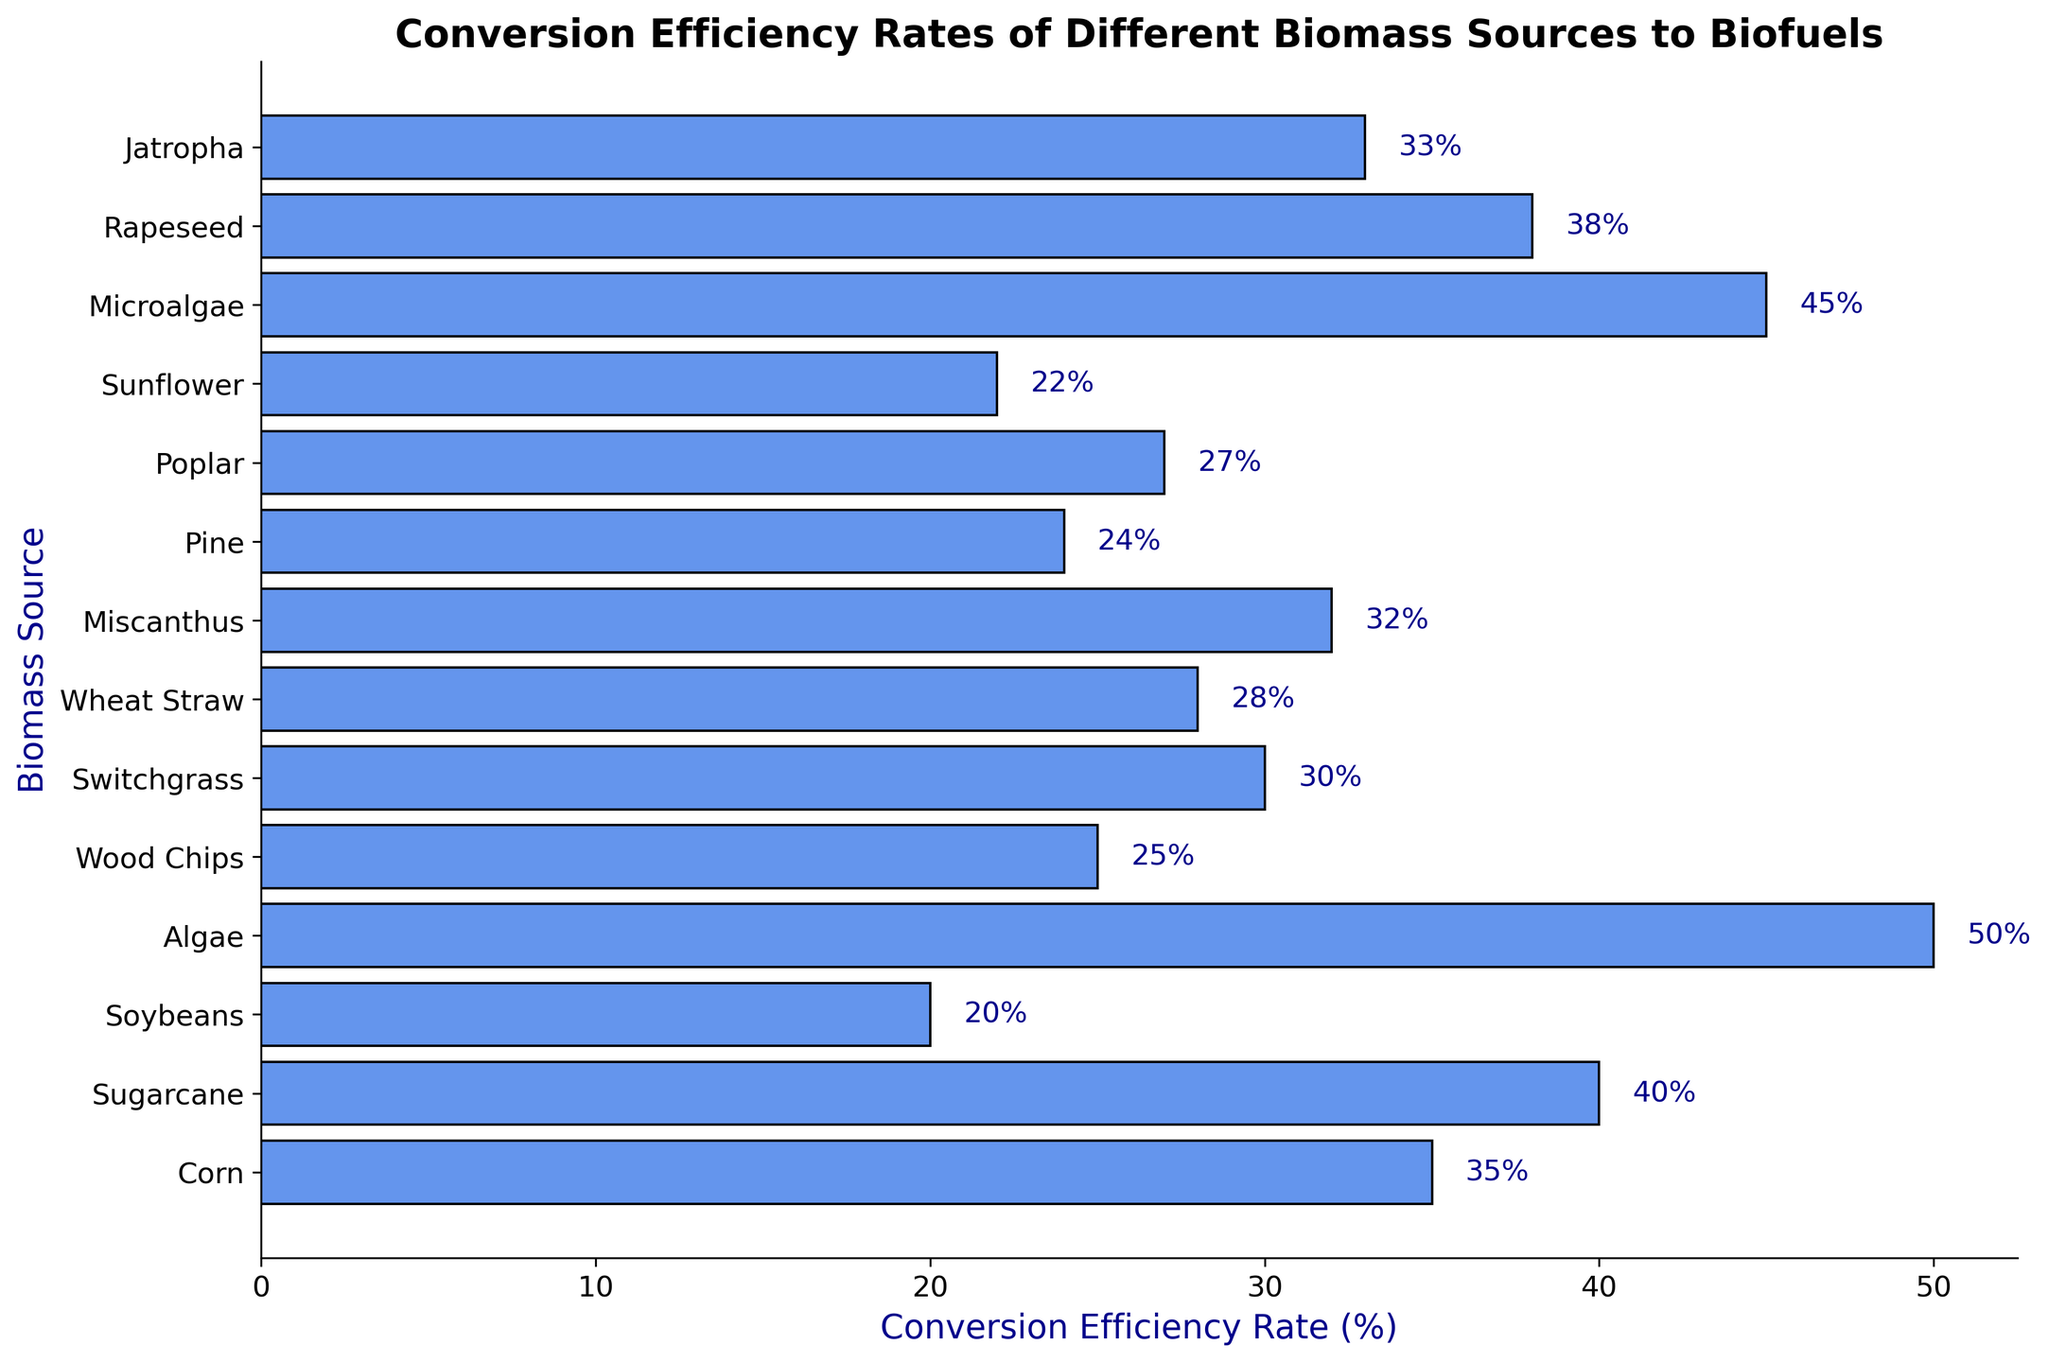Which biomass source has the highest conversion efficiency rate? To find the highest conversion efficiency rate, locate the longest bar on the chart. Algae has the longest bar with a conversion efficiency rate of 50%.
Answer: Algae What is the difference in conversion efficiency rates between Corn and Sugarcane? Look at the conversion efficiency rates for Corn and Sugarcane on the chart. Corn has a rate of 35% and Sugarcane has a rate of 40%. The difference is 40% - 35% = 5%.
Answer: 5% What is the average conversion efficiency rate of Algae, Microalgae, and Jatropha? Sum the conversion rates for Algae (50%), Microalgae (45%), and Jatropha (33%). Then divide by 3 to find the average: (50 + 45 + 33) / 3 = 128 / 3 ≈ 42.67%.
Answer: 42.67% Which biomass sources have a conversion efficiency rate less than 30%? Identify the bars that are below the 30% mark on the x-axis. The sources are Soybeans (20%), Wood Chips (25%), Pine (24%), Poplar (27%), and Sunflower (22%).
Answer: Soybeans, Wood Chips, Pine, Poplar, Sunflower What is the total conversion efficiency rate for Switchgrass and Miscanthus combined? Add the conversion rates for Switchgrass and Miscanthus. Switchgrass has a 30% rate, and Miscanthus has a 32% rate. 30% + 32% = 62%.
Answer: 62% How many biomass sources have a conversion efficiency rate greater than 30% but less than 40%? Identify the bars that are above the 30% mark but below the 40% mark. These sources are Corn (35%), Sugarcane (40%), Switchgrass (30%), Wheat Straw (28%), Miscanthus (32%), Rapeseed (38%), and Jatropha (33%)—with 7 sources fitting into this range. However, since Switchgrass (30%) and Wheat Straw (28%) are actually not within this range, the accurate count is 4. Correction requires recognizing that only Corn (35%), Miscanthus (32%), Rapeseed (38%), and Jatropha (33%) fall in the required range.
Answer: 4 Which biomass has a conversion efficiency rate equal to the color blue, given it symbolizes high rates in this chart? By referring to the figure, identify the biomass sources represented by blue-colored bars. With blue symbolizing high values, the highest conversion rate exceeding 40% is represented by Algae at 50%, Microalgae at 45%. These two are distinguishable than other lower rate.
Answer: Algae, Microalgae 